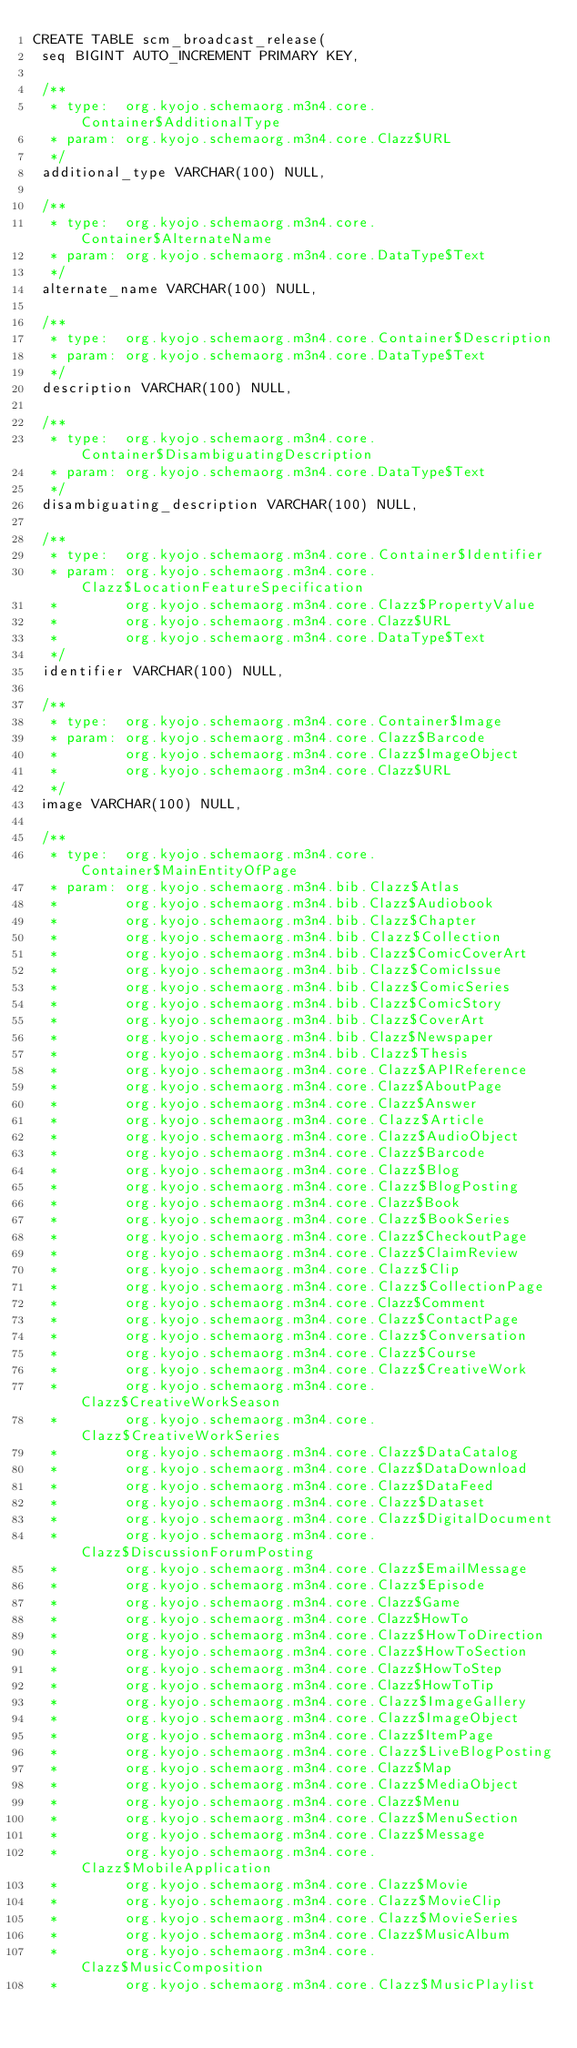Convert code to text. <code><loc_0><loc_0><loc_500><loc_500><_SQL_>CREATE TABLE scm_broadcast_release(
 seq BIGINT AUTO_INCREMENT PRIMARY KEY,

 /**
  * type:  org.kyojo.schemaorg.m3n4.core.Container$AdditionalType
  * param: org.kyojo.schemaorg.m3n4.core.Clazz$URL
  */
 additional_type VARCHAR(100) NULL,

 /**
  * type:  org.kyojo.schemaorg.m3n4.core.Container$AlternateName
  * param: org.kyojo.schemaorg.m3n4.core.DataType$Text
  */
 alternate_name VARCHAR(100) NULL,

 /**
  * type:  org.kyojo.schemaorg.m3n4.core.Container$Description
  * param: org.kyojo.schemaorg.m3n4.core.DataType$Text
  */
 description VARCHAR(100) NULL,

 /**
  * type:  org.kyojo.schemaorg.m3n4.core.Container$DisambiguatingDescription
  * param: org.kyojo.schemaorg.m3n4.core.DataType$Text
  */
 disambiguating_description VARCHAR(100) NULL,

 /**
  * type:  org.kyojo.schemaorg.m3n4.core.Container$Identifier
  * param: org.kyojo.schemaorg.m3n4.core.Clazz$LocationFeatureSpecification
  *        org.kyojo.schemaorg.m3n4.core.Clazz$PropertyValue
  *        org.kyojo.schemaorg.m3n4.core.Clazz$URL
  *        org.kyojo.schemaorg.m3n4.core.DataType$Text
  */
 identifier VARCHAR(100) NULL,

 /**
  * type:  org.kyojo.schemaorg.m3n4.core.Container$Image
  * param: org.kyojo.schemaorg.m3n4.core.Clazz$Barcode
  *        org.kyojo.schemaorg.m3n4.core.Clazz$ImageObject
  *        org.kyojo.schemaorg.m3n4.core.Clazz$URL
  */
 image VARCHAR(100) NULL,

 /**
  * type:  org.kyojo.schemaorg.m3n4.core.Container$MainEntityOfPage
  * param: org.kyojo.schemaorg.m3n4.bib.Clazz$Atlas
  *        org.kyojo.schemaorg.m3n4.bib.Clazz$Audiobook
  *        org.kyojo.schemaorg.m3n4.bib.Clazz$Chapter
  *        org.kyojo.schemaorg.m3n4.bib.Clazz$Collection
  *        org.kyojo.schemaorg.m3n4.bib.Clazz$ComicCoverArt
  *        org.kyojo.schemaorg.m3n4.bib.Clazz$ComicIssue
  *        org.kyojo.schemaorg.m3n4.bib.Clazz$ComicSeries
  *        org.kyojo.schemaorg.m3n4.bib.Clazz$ComicStory
  *        org.kyojo.schemaorg.m3n4.bib.Clazz$CoverArt
  *        org.kyojo.schemaorg.m3n4.bib.Clazz$Newspaper
  *        org.kyojo.schemaorg.m3n4.bib.Clazz$Thesis
  *        org.kyojo.schemaorg.m3n4.core.Clazz$APIReference
  *        org.kyojo.schemaorg.m3n4.core.Clazz$AboutPage
  *        org.kyojo.schemaorg.m3n4.core.Clazz$Answer
  *        org.kyojo.schemaorg.m3n4.core.Clazz$Article
  *        org.kyojo.schemaorg.m3n4.core.Clazz$AudioObject
  *        org.kyojo.schemaorg.m3n4.core.Clazz$Barcode
  *        org.kyojo.schemaorg.m3n4.core.Clazz$Blog
  *        org.kyojo.schemaorg.m3n4.core.Clazz$BlogPosting
  *        org.kyojo.schemaorg.m3n4.core.Clazz$Book
  *        org.kyojo.schemaorg.m3n4.core.Clazz$BookSeries
  *        org.kyojo.schemaorg.m3n4.core.Clazz$CheckoutPage
  *        org.kyojo.schemaorg.m3n4.core.Clazz$ClaimReview
  *        org.kyojo.schemaorg.m3n4.core.Clazz$Clip
  *        org.kyojo.schemaorg.m3n4.core.Clazz$CollectionPage
  *        org.kyojo.schemaorg.m3n4.core.Clazz$Comment
  *        org.kyojo.schemaorg.m3n4.core.Clazz$ContactPage
  *        org.kyojo.schemaorg.m3n4.core.Clazz$Conversation
  *        org.kyojo.schemaorg.m3n4.core.Clazz$Course
  *        org.kyojo.schemaorg.m3n4.core.Clazz$CreativeWork
  *        org.kyojo.schemaorg.m3n4.core.Clazz$CreativeWorkSeason
  *        org.kyojo.schemaorg.m3n4.core.Clazz$CreativeWorkSeries
  *        org.kyojo.schemaorg.m3n4.core.Clazz$DataCatalog
  *        org.kyojo.schemaorg.m3n4.core.Clazz$DataDownload
  *        org.kyojo.schemaorg.m3n4.core.Clazz$DataFeed
  *        org.kyojo.schemaorg.m3n4.core.Clazz$Dataset
  *        org.kyojo.schemaorg.m3n4.core.Clazz$DigitalDocument
  *        org.kyojo.schemaorg.m3n4.core.Clazz$DiscussionForumPosting
  *        org.kyojo.schemaorg.m3n4.core.Clazz$EmailMessage
  *        org.kyojo.schemaorg.m3n4.core.Clazz$Episode
  *        org.kyojo.schemaorg.m3n4.core.Clazz$Game
  *        org.kyojo.schemaorg.m3n4.core.Clazz$HowTo
  *        org.kyojo.schemaorg.m3n4.core.Clazz$HowToDirection
  *        org.kyojo.schemaorg.m3n4.core.Clazz$HowToSection
  *        org.kyojo.schemaorg.m3n4.core.Clazz$HowToStep
  *        org.kyojo.schemaorg.m3n4.core.Clazz$HowToTip
  *        org.kyojo.schemaorg.m3n4.core.Clazz$ImageGallery
  *        org.kyojo.schemaorg.m3n4.core.Clazz$ImageObject
  *        org.kyojo.schemaorg.m3n4.core.Clazz$ItemPage
  *        org.kyojo.schemaorg.m3n4.core.Clazz$LiveBlogPosting
  *        org.kyojo.schemaorg.m3n4.core.Clazz$Map
  *        org.kyojo.schemaorg.m3n4.core.Clazz$MediaObject
  *        org.kyojo.schemaorg.m3n4.core.Clazz$Menu
  *        org.kyojo.schemaorg.m3n4.core.Clazz$MenuSection
  *        org.kyojo.schemaorg.m3n4.core.Clazz$Message
  *        org.kyojo.schemaorg.m3n4.core.Clazz$MobileApplication
  *        org.kyojo.schemaorg.m3n4.core.Clazz$Movie
  *        org.kyojo.schemaorg.m3n4.core.Clazz$MovieClip
  *        org.kyojo.schemaorg.m3n4.core.Clazz$MovieSeries
  *        org.kyojo.schemaorg.m3n4.core.Clazz$MusicAlbum
  *        org.kyojo.schemaorg.m3n4.core.Clazz$MusicComposition
  *        org.kyojo.schemaorg.m3n4.core.Clazz$MusicPlaylist</code> 